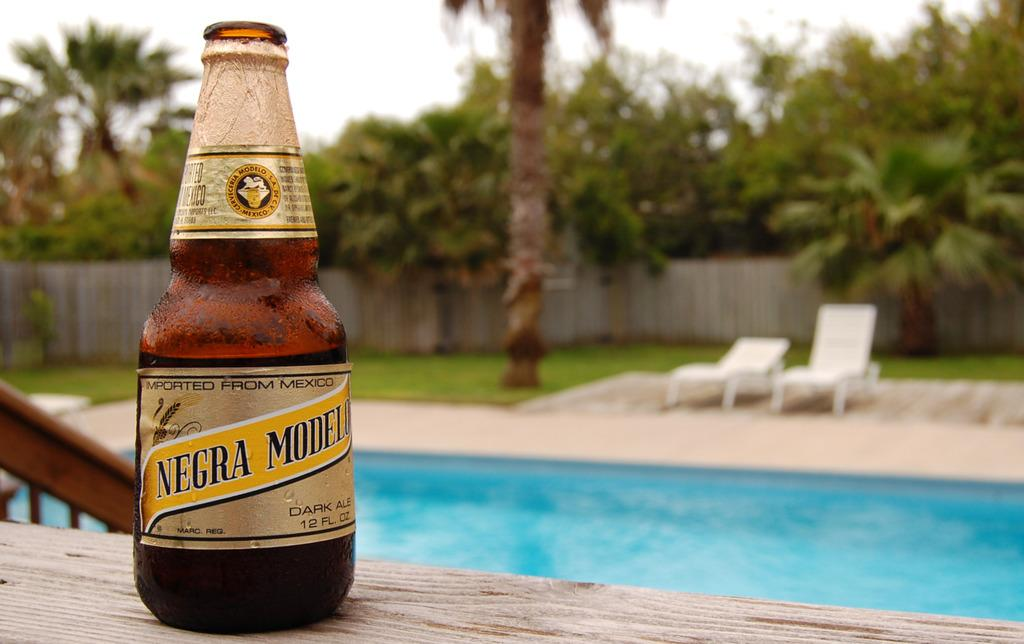<image>
Render a clear and concise summary of the photo. A bottle that is imported from Mexico sits next to a pool. 